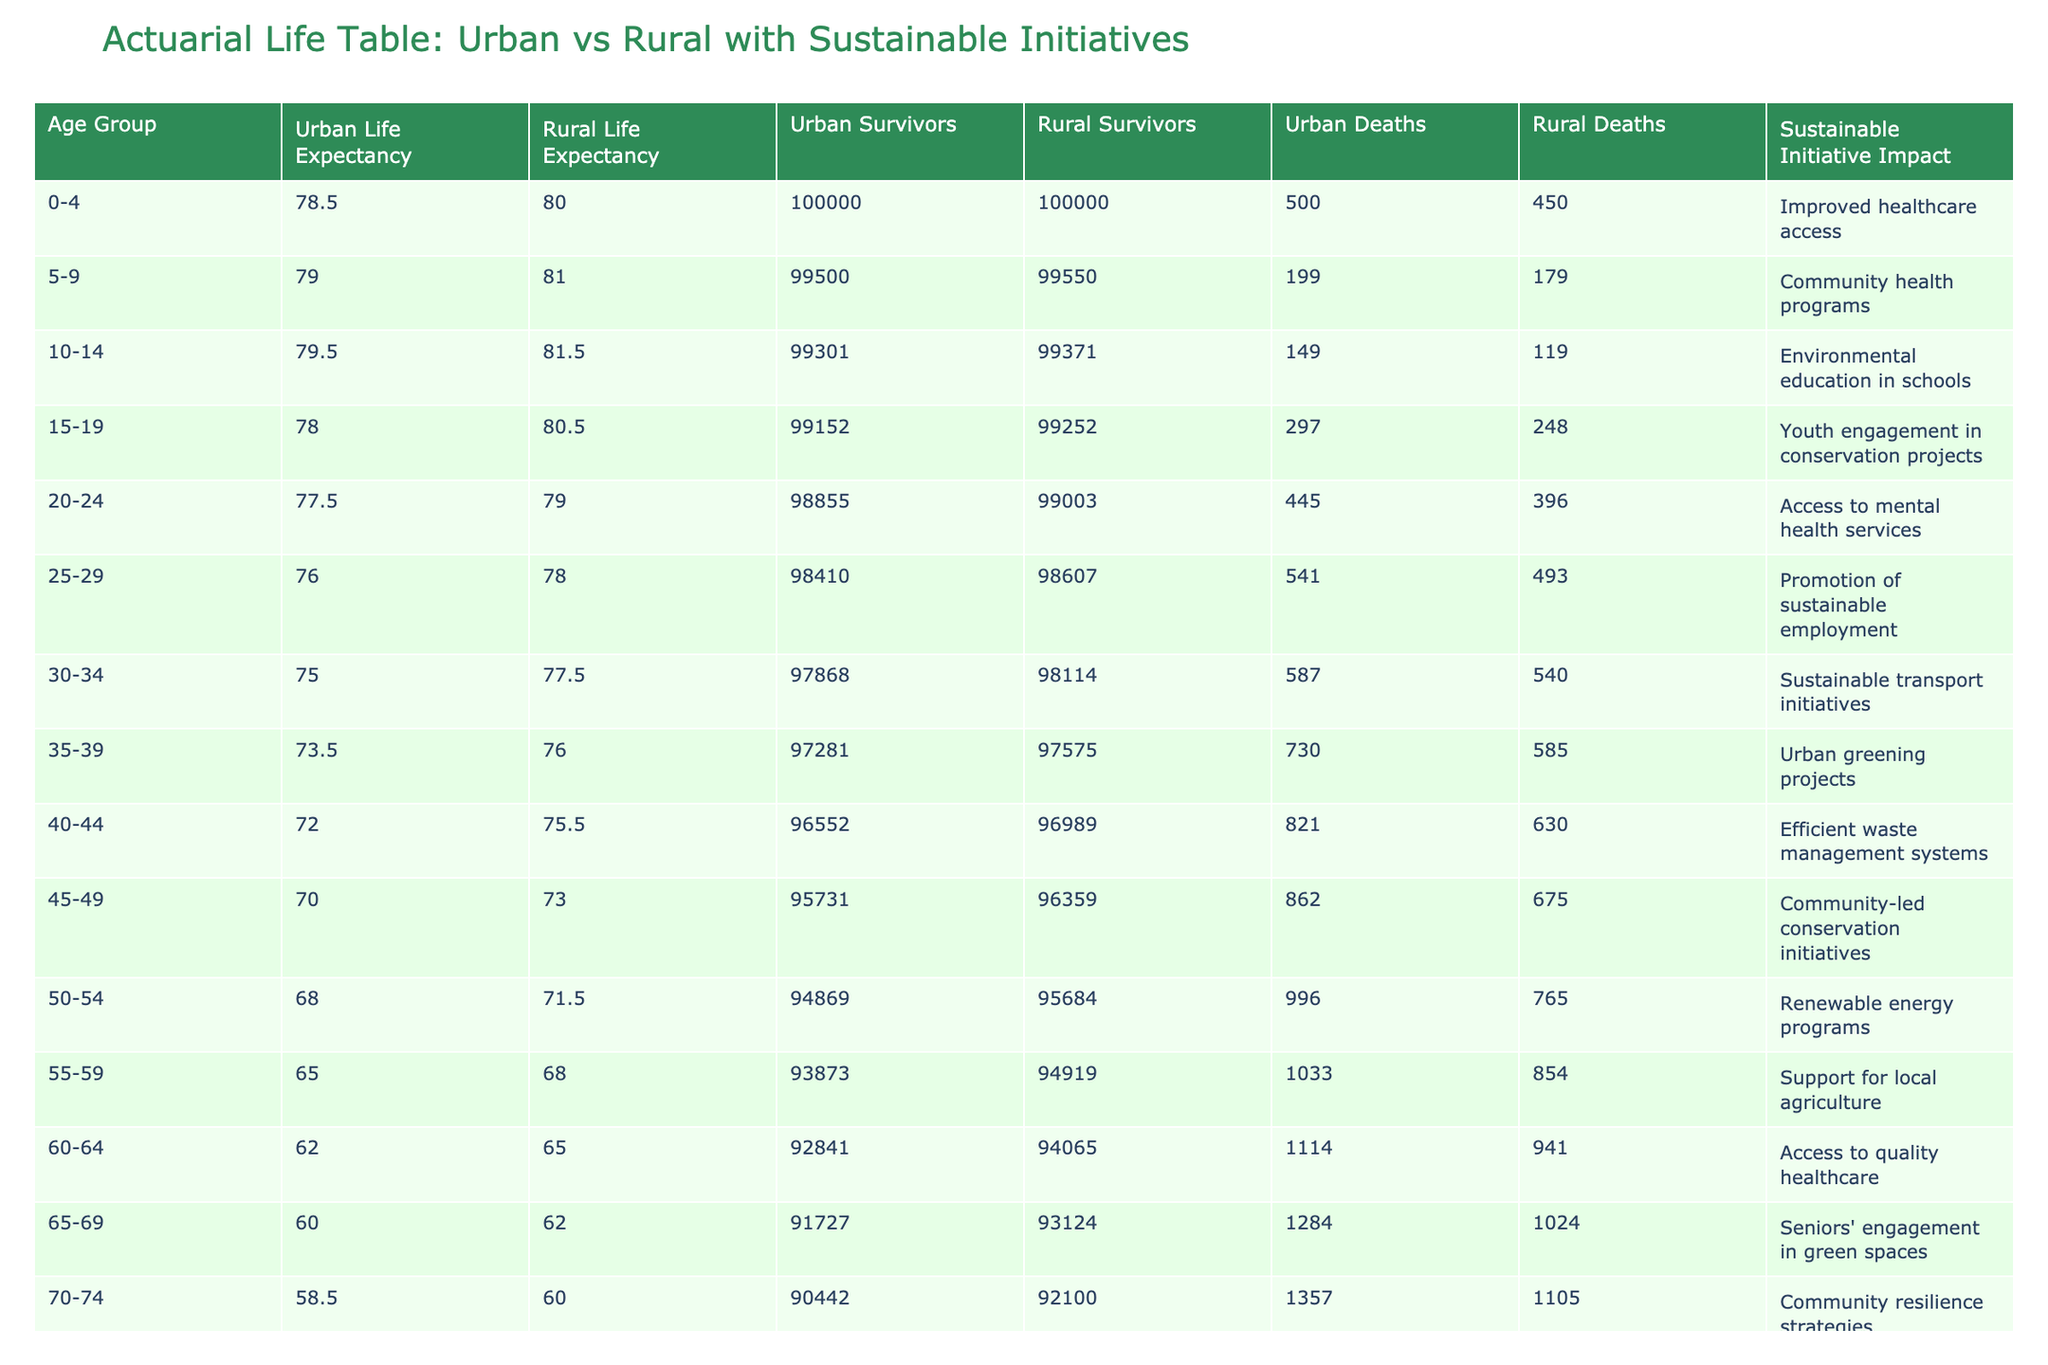What is the urban life expectancy for the age group 30-34? The table indicates that the urban life expectancy for the age group 30-34 is given directly in the column for Urban Life Expectancy. The value stated there is 75.0.
Answer: 75.0 What is the rural death rate for the age group 50-54? By looking at the table, the rural death rate for the age group 50-54 can be found in the Rural Death Rate column. The corresponding value is 0.008.
Answer: 0.008 Which age group shows the highest difference in life expectancy between urban and rural settings? To determine this, we need to subtract the urban life expectancy from the rural life expectancy for each age group and compare the differences. The largest difference is 4.5 years, observed in the age group 35-39 (76.0 - 73.5).
Answer: 4.5 years Is the sustainable initiative impact for the age group 15-19 related to community programs? Checking the Sustainable Initiative Impact column, the age group 15-19 is associated with "Youth engagement in conservation projects", which does relate to community-focused efforts aimed at conservation.
Answer: Yes What is the average life expectancy for both urban and rural settings combined for the age group 40-44? To find this, we take the urban life expectancy (72.0) and the rural life expectancy (75.5) for age 40-44, add them together (72.0 + 75.5 = 147.5), and then divide by 2 to obtain the average. The calculation yields an average life expectancy of 73.75.
Answer: 73.75 